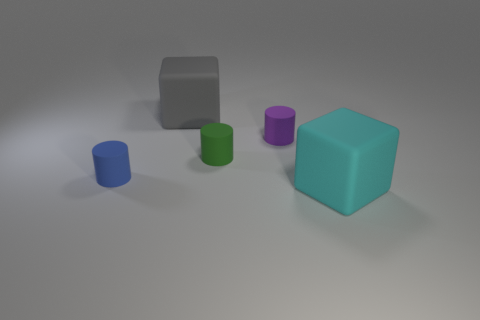Can you tell what time of day it is or what the setting might be based on the lighting in the image? The image appears to be taken in a neutral space with a diffuse, artificial light source. There's no indication of natural light or any recognizable indoor or outdoor features to suggest a specific time of day or setting. Could the arrangement of the objects have any significance? The arrangement seems random without clear patterns or groupings, suggesting no intentional significance. It may simply be a display of the objects' various shapes and colors. 